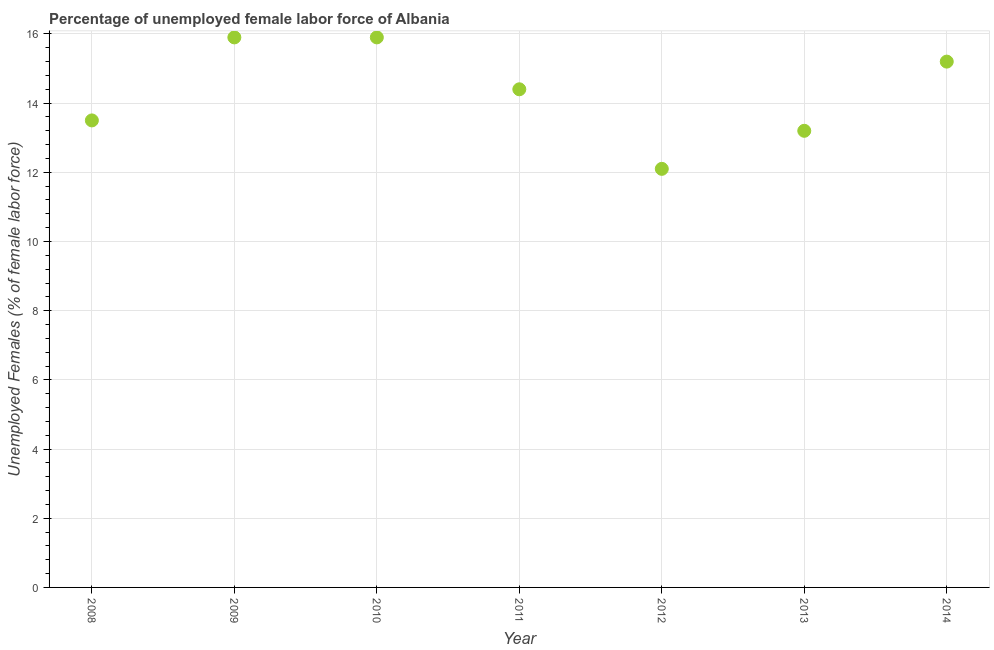What is the total unemployed female labour force in 2011?
Offer a terse response. 14.4. Across all years, what is the maximum total unemployed female labour force?
Offer a very short reply. 15.9. Across all years, what is the minimum total unemployed female labour force?
Your answer should be compact. 12.1. What is the sum of the total unemployed female labour force?
Keep it short and to the point. 100.2. What is the difference between the total unemployed female labour force in 2009 and 2013?
Make the answer very short. 2.7. What is the average total unemployed female labour force per year?
Keep it short and to the point. 14.31. What is the median total unemployed female labour force?
Your answer should be compact. 14.4. Do a majority of the years between 2008 and 2014 (inclusive) have total unemployed female labour force greater than 8.4 %?
Make the answer very short. Yes. What is the ratio of the total unemployed female labour force in 2009 to that in 2014?
Your response must be concise. 1.05. What is the difference between the highest and the lowest total unemployed female labour force?
Keep it short and to the point. 3.8. Does the total unemployed female labour force monotonically increase over the years?
Ensure brevity in your answer.  No. How many dotlines are there?
Give a very brief answer. 1. Are the values on the major ticks of Y-axis written in scientific E-notation?
Provide a short and direct response. No. What is the title of the graph?
Your response must be concise. Percentage of unemployed female labor force of Albania. What is the label or title of the X-axis?
Offer a very short reply. Year. What is the label or title of the Y-axis?
Keep it short and to the point. Unemployed Females (% of female labor force). What is the Unemployed Females (% of female labor force) in 2008?
Provide a succinct answer. 13.5. What is the Unemployed Females (% of female labor force) in 2009?
Your answer should be compact. 15.9. What is the Unemployed Females (% of female labor force) in 2010?
Keep it short and to the point. 15.9. What is the Unemployed Females (% of female labor force) in 2011?
Give a very brief answer. 14.4. What is the Unemployed Females (% of female labor force) in 2012?
Your response must be concise. 12.1. What is the Unemployed Females (% of female labor force) in 2013?
Ensure brevity in your answer.  13.2. What is the Unemployed Females (% of female labor force) in 2014?
Offer a terse response. 15.2. What is the difference between the Unemployed Females (% of female labor force) in 2008 and 2009?
Provide a succinct answer. -2.4. What is the difference between the Unemployed Females (% of female labor force) in 2008 and 2012?
Your response must be concise. 1.4. What is the difference between the Unemployed Females (% of female labor force) in 2008 and 2014?
Offer a terse response. -1.7. What is the difference between the Unemployed Females (% of female labor force) in 2009 and 2011?
Make the answer very short. 1.5. What is the difference between the Unemployed Females (% of female labor force) in 2009 and 2014?
Make the answer very short. 0.7. What is the difference between the Unemployed Females (% of female labor force) in 2010 and 2013?
Your response must be concise. 2.7. What is the difference between the Unemployed Females (% of female labor force) in 2010 and 2014?
Offer a terse response. 0.7. What is the difference between the Unemployed Females (% of female labor force) in 2011 and 2013?
Keep it short and to the point. 1.2. What is the difference between the Unemployed Females (% of female labor force) in 2011 and 2014?
Your answer should be compact. -0.8. What is the difference between the Unemployed Females (% of female labor force) in 2012 and 2013?
Your answer should be compact. -1.1. What is the difference between the Unemployed Females (% of female labor force) in 2012 and 2014?
Your answer should be very brief. -3.1. What is the difference between the Unemployed Females (% of female labor force) in 2013 and 2014?
Provide a short and direct response. -2. What is the ratio of the Unemployed Females (% of female labor force) in 2008 to that in 2009?
Your answer should be very brief. 0.85. What is the ratio of the Unemployed Females (% of female labor force) in 2008 to that in 2010?
Offer a terse response. 0.85. What is the ratio of the Unemployed Females (% of female labor force) in 2008 to that in 2011?
Keep it short and to the point. 0.94. What is the ratio of the Unemployed Females (% of female labor force) in 2008 to that in 2012?
Your response must be concise. 1.12. What is the ratio of the Unemployed Females (% of female labor force) in 2008 to that in 2014?
Ensure brevity in your answer.  0.89. What is the ratio of the Unemployed Females (% of female labor force) in 2009 to that in 2011?
Ensure brevity in your answer.  1.1. What is the ratio of the Unemployed Females (% of female labor force) in 2009 to that in 2012?
Offer a terse response. 1.31. What is the ratio of the Unemployed Females (% of female labor force) in 2009 to that in 2013?
Ensure brevity in your answer.  1.21. What is the ratio of the Unemployed Females (% of female labor force) in 2009 to that in 2014?
Give a very brief answer. 1.05. What is the ratio of the Unemployed Females (% of female labor force) in 2010 to that in 2011?
Provide a short and direct response. 1.1. What is the ratio of the Unemployed Females (% of female labor force) in 2010 to that in 2012?
Give a very brief answer. 1.31. What is the ratio of the Unemployed Females (% of female labor force) in 2010 to that in 2013?
Your answer should be compact. 1.21. What is the ratio of the Unemployed Females (% of female labor force) in 2010 to that in 2014?
Provide a short and direct response. 1.05. What is the ratio of the Unemployed Females (% of female labor force) in 2011 to that in 2012?
Make the answer very short. 1.19. What is the ratio of the Unemployed Females (% of female labor force) in 2011 to that in 2013?
Provide a succinct answer. 1.09. What is the ratio of the Unemployed Females (% of female labor force) in 2011 to that in 2014?
Give a very brief answer. 0.95. What is the ratio of the Unemployed Females (% of female labor force) in 2012 to that in 2013?
Your answer should be compact. 0.92. What is the ratio of the Unemployed Females (% of female labor force) in 2012 to that in 2014?
Offer a very short reply. 0.8. What is the ratio of the Unemployed Females (% of female labor force) in 2013 to that in 2014?
Give a very brief answer. 0.87. 